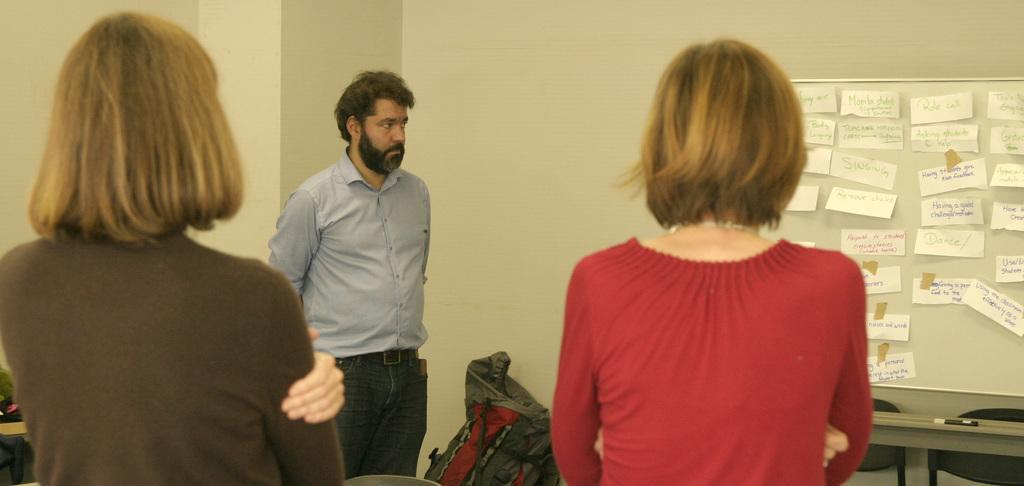How would you summarize this image in a sentence or two? In the picture we can see a man standing and he is with beard and in front of him we can see two women standing and beside her we can see a white colored board to the wall and on it we can see some slips with something written on it and near to it we can see a table on it we can see a marker and behind it we can see some chairs and near the man we can see a bag on the floor. 